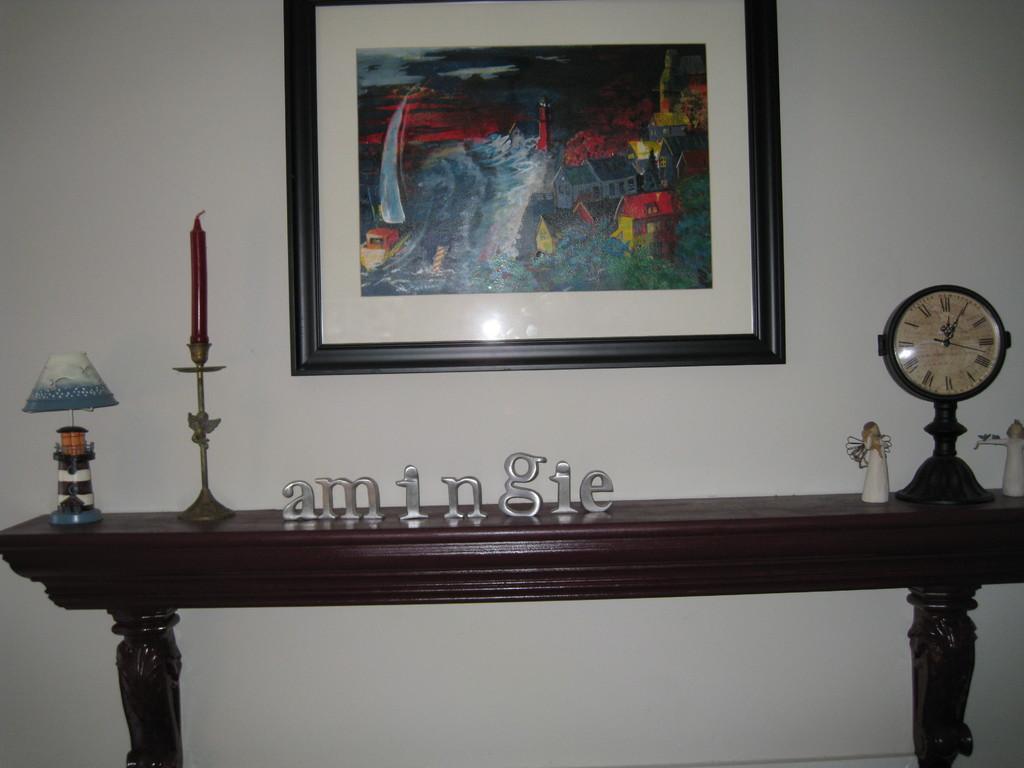What time is it?
Your response must be concise. 12:05. 